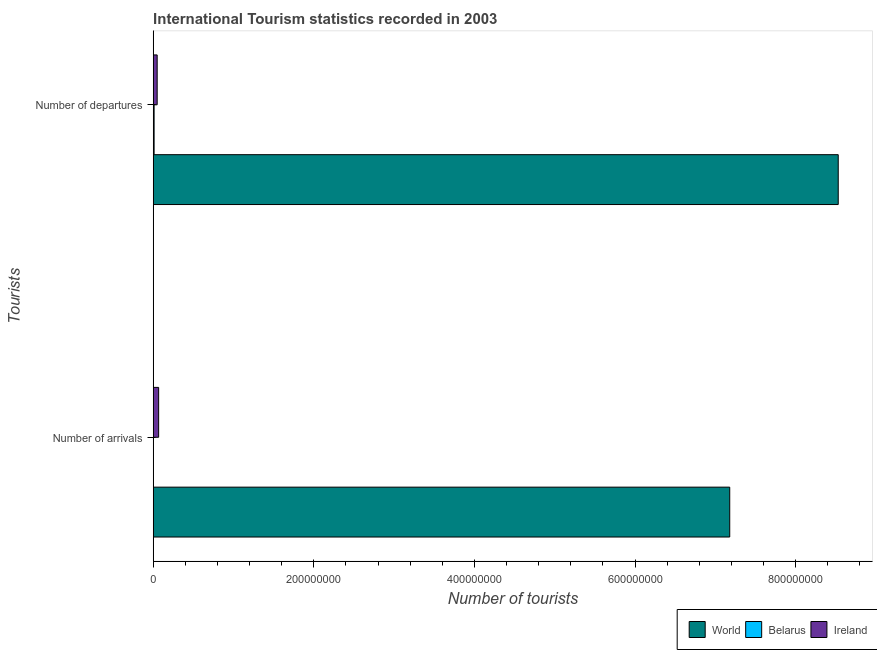How many different coloured bars are there?
Your answer should be compact. 3. Are the number of bars per tick equal to the number of legend labels?
Ensure brevity in your answer.  Yes. How many bars are there on the 2nd tick from the bottom?
Offer a very short reply. 3. What is the label of the 2nd group of bars from the top?
Your answer should be compact. Number of arrivals. What is the number of tourist arrivals in Ireland?
Your answer should be compact. 6.76e+06. Across all countries, what is the maximum number of tourist arrivals?
Keep it short and to the point. 7.18e+08. Across all countries, what is the minimum number of tourist arrivals?
Make the answer very short. 6.40e+04. In which country was the number of tourist arrivals maximum?
Ensure brevity in your answer.  World. In which country was the number of tourist departures minimum?
Provide a short and direct response. Belarus. What is the total number of tourist departures in the graph?
Your answer should be compact. 8.59e+08. What is the difference between the number of tourist arrivals in World and that in Belarus?
Provide a succinct answer. 7.18e+08. What is the difference between the number of tourist departures in World and the number of tourist arrivals in Ireland?
Offer a very short reply. 8.46e+08. What is the average number of tourist arrivals per country?
Give a very brief answer. 2.42e+08. What is the difference between the number of tourist arrivals and number of tourist departures in World?
Your answer should be compact. -1.35e+08. What is the ratio of the number of tourist arrivals in Belarus to that in Ireland?
Your answer should be very brief. 0.01. In how many countries, is the number of tourist arrivals greater than the average number of tourist arrivals taken over all countries?
Offer a terse response. 1. What does the 3rd bar from the top in Number of departures represents?
Offer a terse response. World. What does the 3rd bar from the bottom in Number of departures represents?
Make the answer very short. Ireland. Are all the bars in the graph horizontal?
Offer a very short reply. Yes. Does the graph contain grids?
Offer a terse response. No. What is the title of the graph?
Offer a terse response. International Tourism statistics recorded in 2003. Does "Liechtenstein" appear as one of the legend labels in the graph?
Your answer should be very brief. No. What is the label or title of the X-axis?
Give a very brief answer. Number of tourists. What is the label or title of the Y-axis?
Make the answer very short. Tourists. What is the Number of tourists in World in Number of arrivals?
Offer a very short reply. 7.18e+08. What is the Number of tourists of Belarus in Number of arrivals?
Your response must be concise. 6.40e+04. What is the Number of tourists in Ireland in Number of arrivals?
Keep it short and to the point. 6.76e+06. What is the Number of tourists of World in Number of departures?
Provide a succinct answer. 8.53e+08. What is the Number of tourists in Belarus in Number of departures?
Make the answer very short. 1.11e+06. What is the Number of tourists of Ireland in Number of departures?
Offer a terse response. 4.93e+06. Across all Tourists, what is the maximum Number of tourists in World?
Your answer should be compact. 8.53e+08. Across all Tourists, what is the maximum Number of tourists of Belarus?
Offer a very short reply. 1.11e+06. Across all Tourists, what is the maximum Number of tourists of Ireland?
Provide a short and direct response. 6.76e+06. Across all Tourists, what is the minimum Number of tourists of World?
Offer a very short reply. 7.18e+08. Across all Tourists, what is the minimum Number of tourists in Belarus?
Your response must be concise. 6.40e+04. Across all Tourists, what is the minimum Number of tourists of Ireland?
Ensure brevity in your answer.  4.93e+06. What is the total Number of tourists in World in the graph?
Offer a terse response. 1.57e+09. What is the total Number of tourists of Belarus in the graph?
Make the answer very short. 1.17e+06. What is the total Number of tourists in Ireland in the graph?
Keep it short and to the point. 1.17e+07. What is the difference between the Number of tourists of World in Number of arrivals and that in Number of departures?
Offer a terse response. -1.35e+08. What is the difference between the Number of tourists in Belarus in Number of arrivals and that in Number of departures?
Provide a short and direct response. -1.04e+06. What is the difference between the Number of tourists of Ireland in Number of arrivals and that in Number of departures?
Your response must be concise. 1.84e+06. What is the difference between the Number of tourists of World in Number of arrivals and the Number of tourists of Belarus in Number of departures?
Ensure brevity in your answer.  7.17e+08. What is the difference between the Number of tourists of World in Number of arrivals and the Number of tourists of Ireland in Number of departures?
Your response must be concise. 7.13e+08. What is the difference between the Number of tourists of Belarus in Number of arrivals and the Number of tourists of Ireland in Number of departures?
Offer a terse response. -4.86e+06. What is the average Number of tourists of World per Tourists?
Your response must be concise. 7.85e+08. What is the average Number of tourists in Belarus per Tourists?
Your answer should be compact. 5.86e+05. What is the average Number of tourists of Ireland per Tourists?
Offer a very short reply. 5.85e+06. What is the difference between the Number of tourists of World and Number of tourists of Belarus in Number of arrivals?
Your answer should be very brief. 7.18e+08. What is the difference between the Number of tourists of World and Number of tourists of Ireland in Number of arrivals?
Keep it short and to the point. 7.11e+08. What is the difference between the Number of tourists in Belarus and Number of tourists in Ireland in Number of arrivals?
Keep it short and to the point. -6.70e+06. What is the difference between the Number of tourists of World and Number of tourists of Belarus in Number of departures?
Give a very brief answer. 8.52e+08. What is the difference between the Number of tourists of World and Number of tourists of Ireland in Number of departures?
Keep it short and to the point. 8.48e+08. What is the difference between the Number of tourists in Belarus and Number of tourists in Ireland in Number of departures?
Ensure brevity in your answer.  -3.82e+06. What is the ratio of the Number of tourists in World in Number of arrivals to that in Number of departures?
Your answer should be compact. 0.84. What is the ratio of the Number of tourists of Belarus in Number of arrivals to that in Number of departures?
Your answer should be compact. 0.06. What is the ratio of the Number of tourists in Ireland in Number of arrivals to that in Number of departures?
Your answer should be very brief. 1.37. What is the difference between the highest and the second highest Number of tourists in World?
Your response must be concise. 1.35e+08. What is the difference between the highest and the second highest Number of tourists of Belarus?
Your answer should be very brief. 1.04e+06. What is the difference between the highest and the second highest Number of tourists in Ireland?
Keep it short and to the point. 1.84e+06. What is the difference between the highest and the lowest Number of tourists of World?
Make the answer very short. 1.35e+08. What is the difference between the highest and the lowest Number of tourists of Belarus?
Offer a terse response. 1.04e+06. What is the difference between the highest and the lowest Number of tourists of Ireland?
Ensure brevity in your answer.  1.84e+06. 